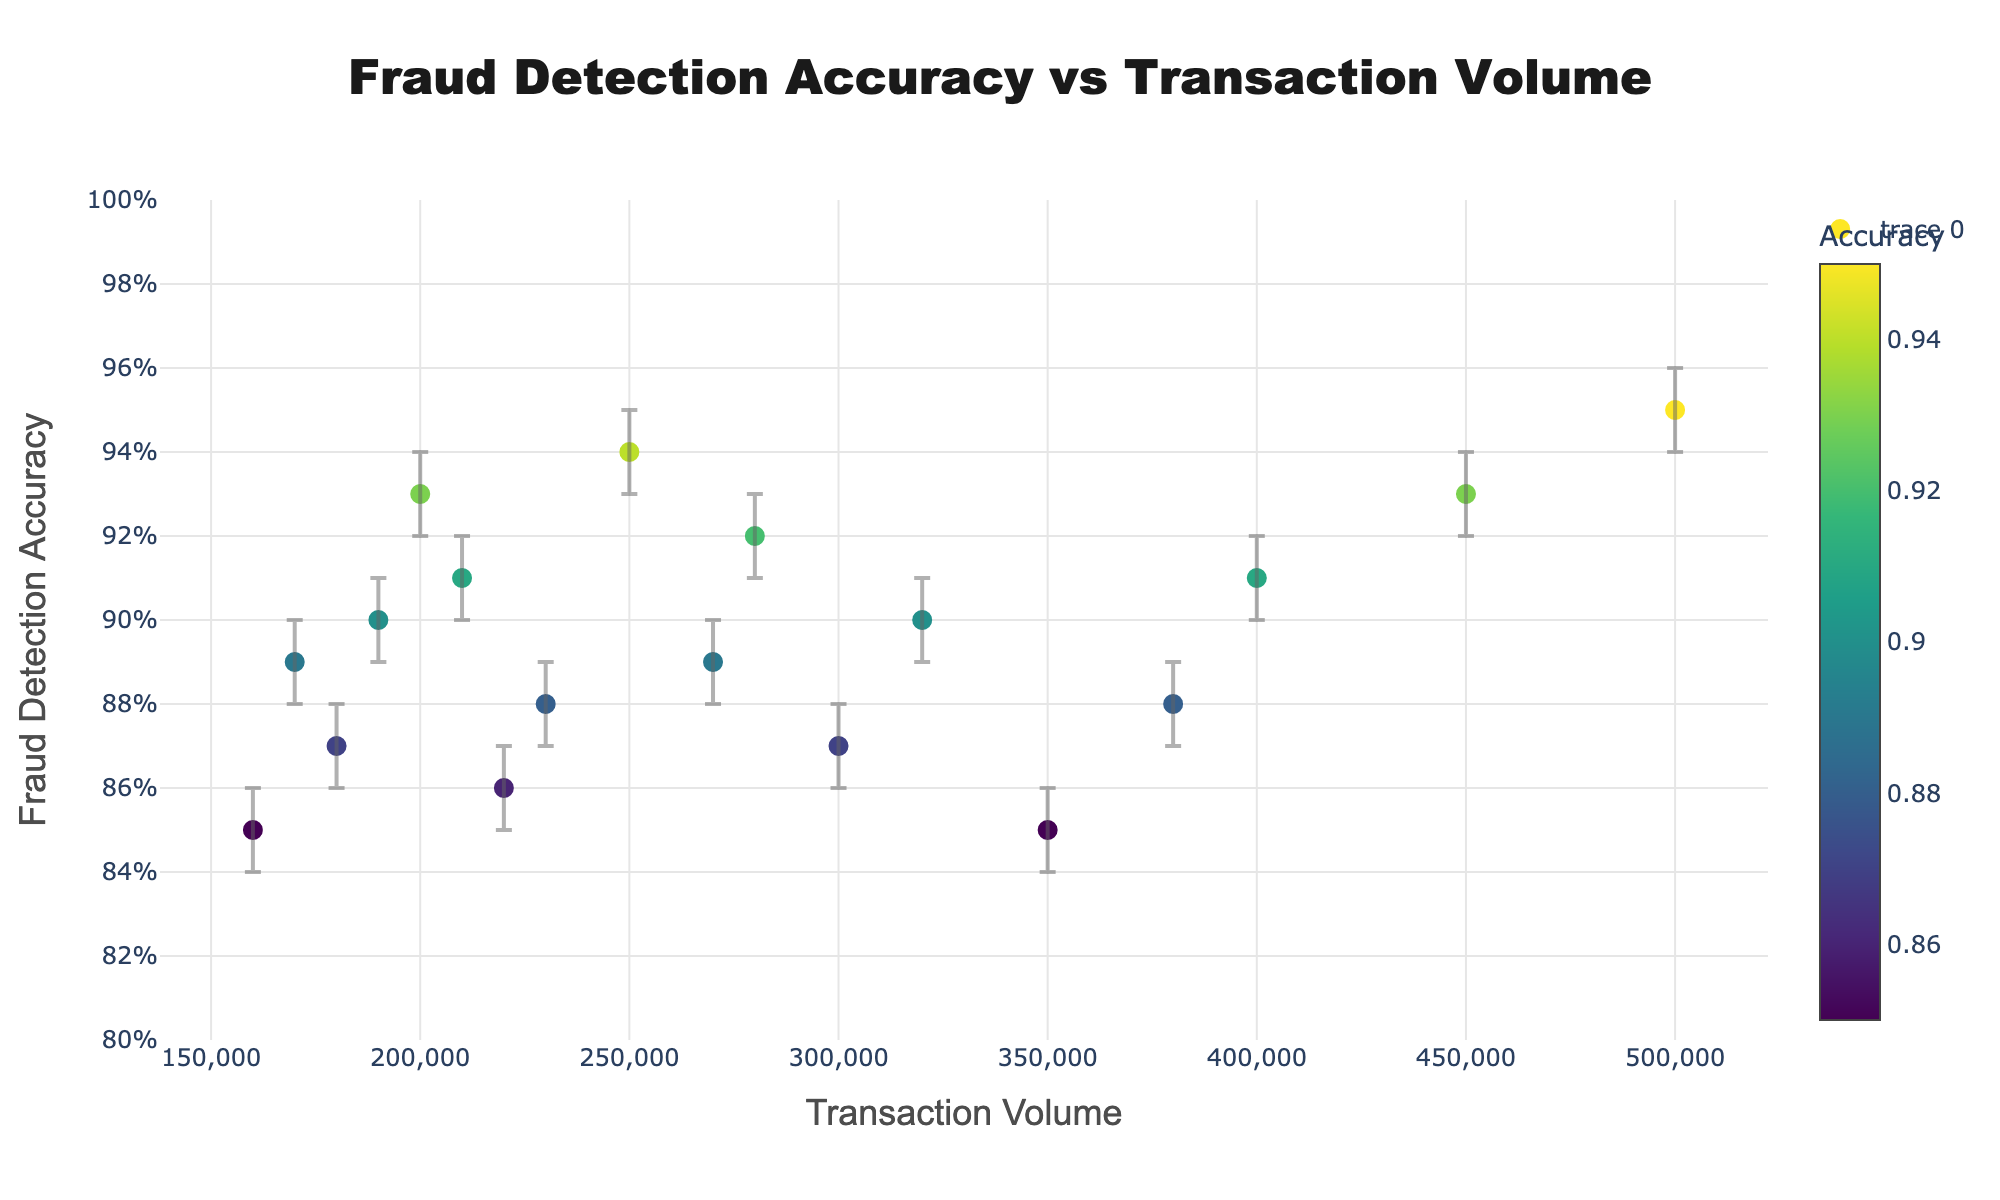What's the title of the figure? The title is located at the top center of the scatter plot.
Answer: Fraud Detection Accuracy vs Transaction Volume What is the range of the y-axis? The range of the y-axis is shown on the left side of the plot.
Answer: From 0.8 to 1 Which financial service has the highest transaction volume and what is its fraud detection accuracy? To find this, locate the data point farthest to the right on the x-axis and check its y-value.
Answer: Bank_of_America, 0.95 Which financial service shows the highest fraud detection accuracy and what is its transaction volume? Look for the data point with the highest position on the y-axis and check its x-value.
Answer: Bank_of_America, 500000 What is the financial service with the lowest fraud detection accuracy and how does it compare in transaction volume to Bank_of_America? Identify the lowest point on the y-axis and compare its x-value with the x-value of Bank_of_America.
Answer: Standard_Chartered, 160000, less than 500000 What's the range of the fraud detection accuracy for Citibank including error bars? To find this, refer to the error bars on the data point for Citibank.
Answer: From 0.87 to 0.89 Which financial service has a higher fraud detection accuracy, UBS or JPMorgan Chase? Compare the y-values of the two data points for UBS and Chase_Bank.
Answer: UBS Among HSBC, Barclays, and ING, which financial service has the smallest transaction volume? Compare the x-values of these three data points to find the smallest one.
Answer: ING Is there a clear trend between transaction volume and fraud detection accuracy? By observing the scatter plot as a whole, one can determine if there's a pattern or correlation.
Answer: No clear trend 